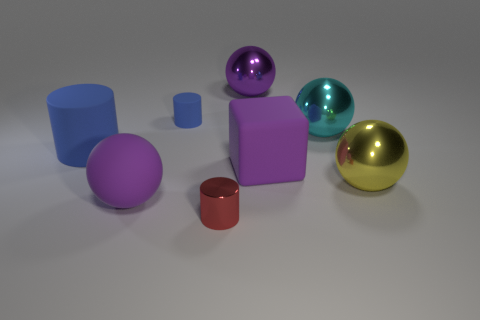What number of other objects are the same material as the small blue object?
Make the answer very short. 3. Is the material of the tiny blue object the same as the large blue object?
Give a very brief answer. Yes. How many big purple spheres are behind the purple sphere on the left side of the small red thing?
Your response must be concise. 1. Is the size of the red cylinder the same as the yellow object?
Give a very brief answer. No. How many purple balls are the same material as the large blue cylinder?
Keep it short and to the point. 1. There is a purple metallic thing that is the same shape as the large yellow object; what is its size?
Provide a succinct answer. Large. There is a purple matte thing to the left of the small blue cylinder; is its shape the same as the large cyan metallic object?
Your answer should be very brief. Yes. The large purple thing in front of the large metallic ball that is in front of the large blue thing is what shape?
Offer a terse response. Sphere. There is a large matte thing that is the same shape as the yellow metallic thing; what is its color?
Keep it short and to the point. Purple. There is a rubber block; does it have the same color as the metal sphere left of the purple block?
Your answer should be compact. Yes. 